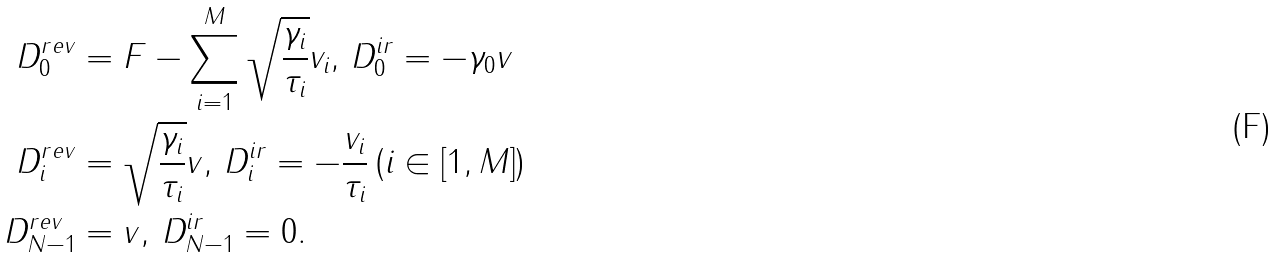Convert formula to latex. <formula><loc_0><loc_0><loc_500><loc_500>D _ { 0 } ^ { r e v } & = F - \sum _ { i = 1 } ^ { M } \sqrt { \frac { \gamma _ { i } } { \tau _ { i } } } v _ { i } , \, D _ { 0 } ^ { i r } = - \gamma _ { 0 } v \\ D _ { i } ^ { r e v } & = \sqrt { \frac { \gamma _ { i } } { \tau _ { i } } } v , \, D _ { i } ^ { i r } = - \frac { v _ { i } } { \tau _ { i } } \, ( i \in [ 1 , M ] ) \\ D _ { N - 1 } ^ { r e v } & = v , \, D _ { N - 1 } ^ { i r } = 0 .</formula> 